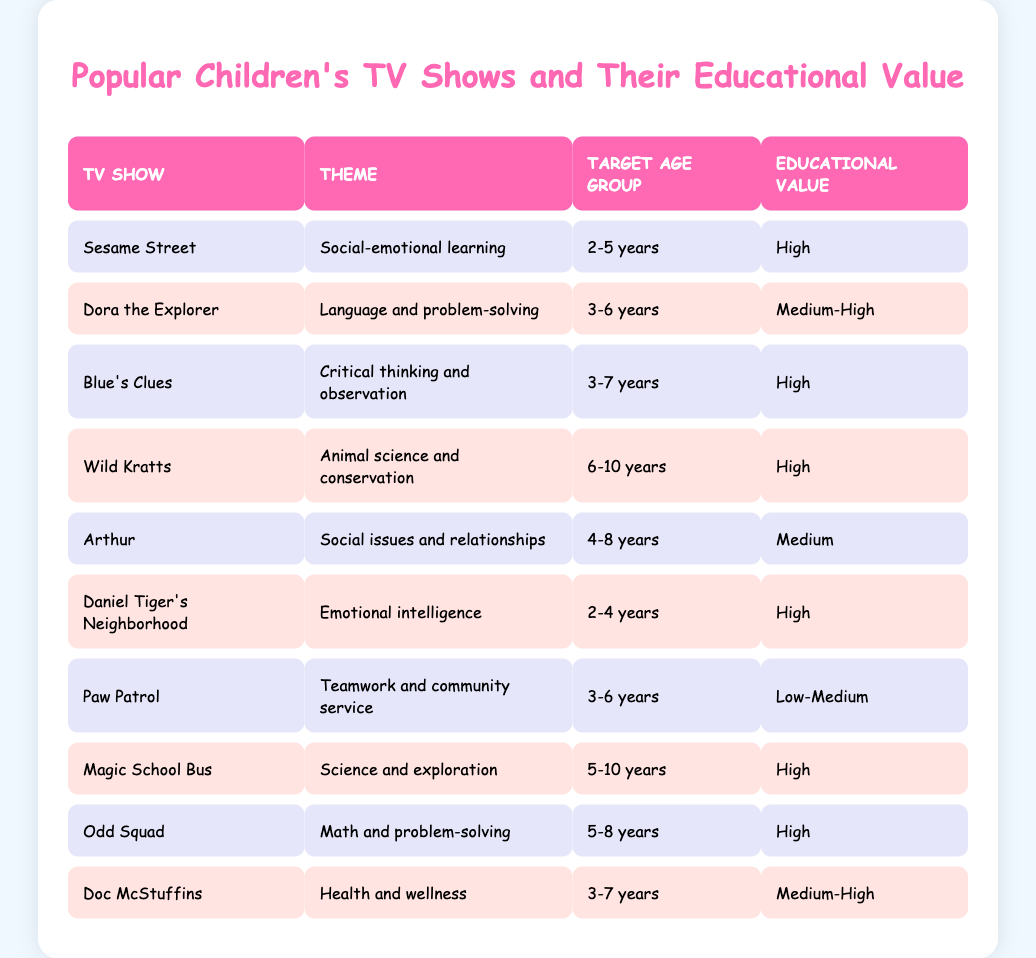What is the educational value of "Dora the Explorer"? The table shows that "Dora the Explorer" has a medium-high educational value.
Answer: Medium-High Which show focuses on animal science and conservation? According to the table, "Wild Kratts" focuses on animal science and conservation.
Answer: Wild Kratts How many shows are targeted at the age group of 3-6 years? The shows targeted at 3-6 years are "Dora the Explorer", "Blue's Clues", "Daniel Tiger's Neighborhood", and "Paw Patrol". This totals to four shows.
Answer: 4 Is "Paw Patrol" considered to have high educational value? Referring to the table, "Paw Patrol" has a low-medium educational value, so it is not considered high.
Answer: No Which show has the highest educational value that is aimed at 2-4 year-olds? From the table, "Daniel Tiger's Neighborhood" has the highest educational value for the age group of 2-4 years with a high rating.
Answer: Daniel Tiger's Neighborhood What is the difference in educational value between "Arthur" and "Wild Kratts"? "Arthur" has a medium educational value, while "Wild Kratts" has a high educational value. The difference between high and medium is one level.
Answer: 1 Are there more shows that promote critical thinking or emotional intelligence? The table shows that there are three shows that promote critical thinking ("Blue's Clues", "Odd Squad") and two shows that promote emotional intelligence ("Daniel Tiger's Neighborhood"). Therefore, there are more shows focused on critical thinking.
Answer: Yes List the themes of shows targeted at 5-10 year-olds. The shows targeted at 5-10 years, based on the table, are "Wild Kratts", "Magic School Bus", and "Odd Squad". Their themes are "Animal science and conservation", "Science and exploration", and "Math and problem-solving" respectively.
Answer: Animal science, Science and exploration, Math and problem-solving What show has a low educational value but targets children aged 3-6? According to the table, "Paw Patrol" is the show that has a low-medium educational value and targets children aged 3-6.
Answer: Paw Patrol 